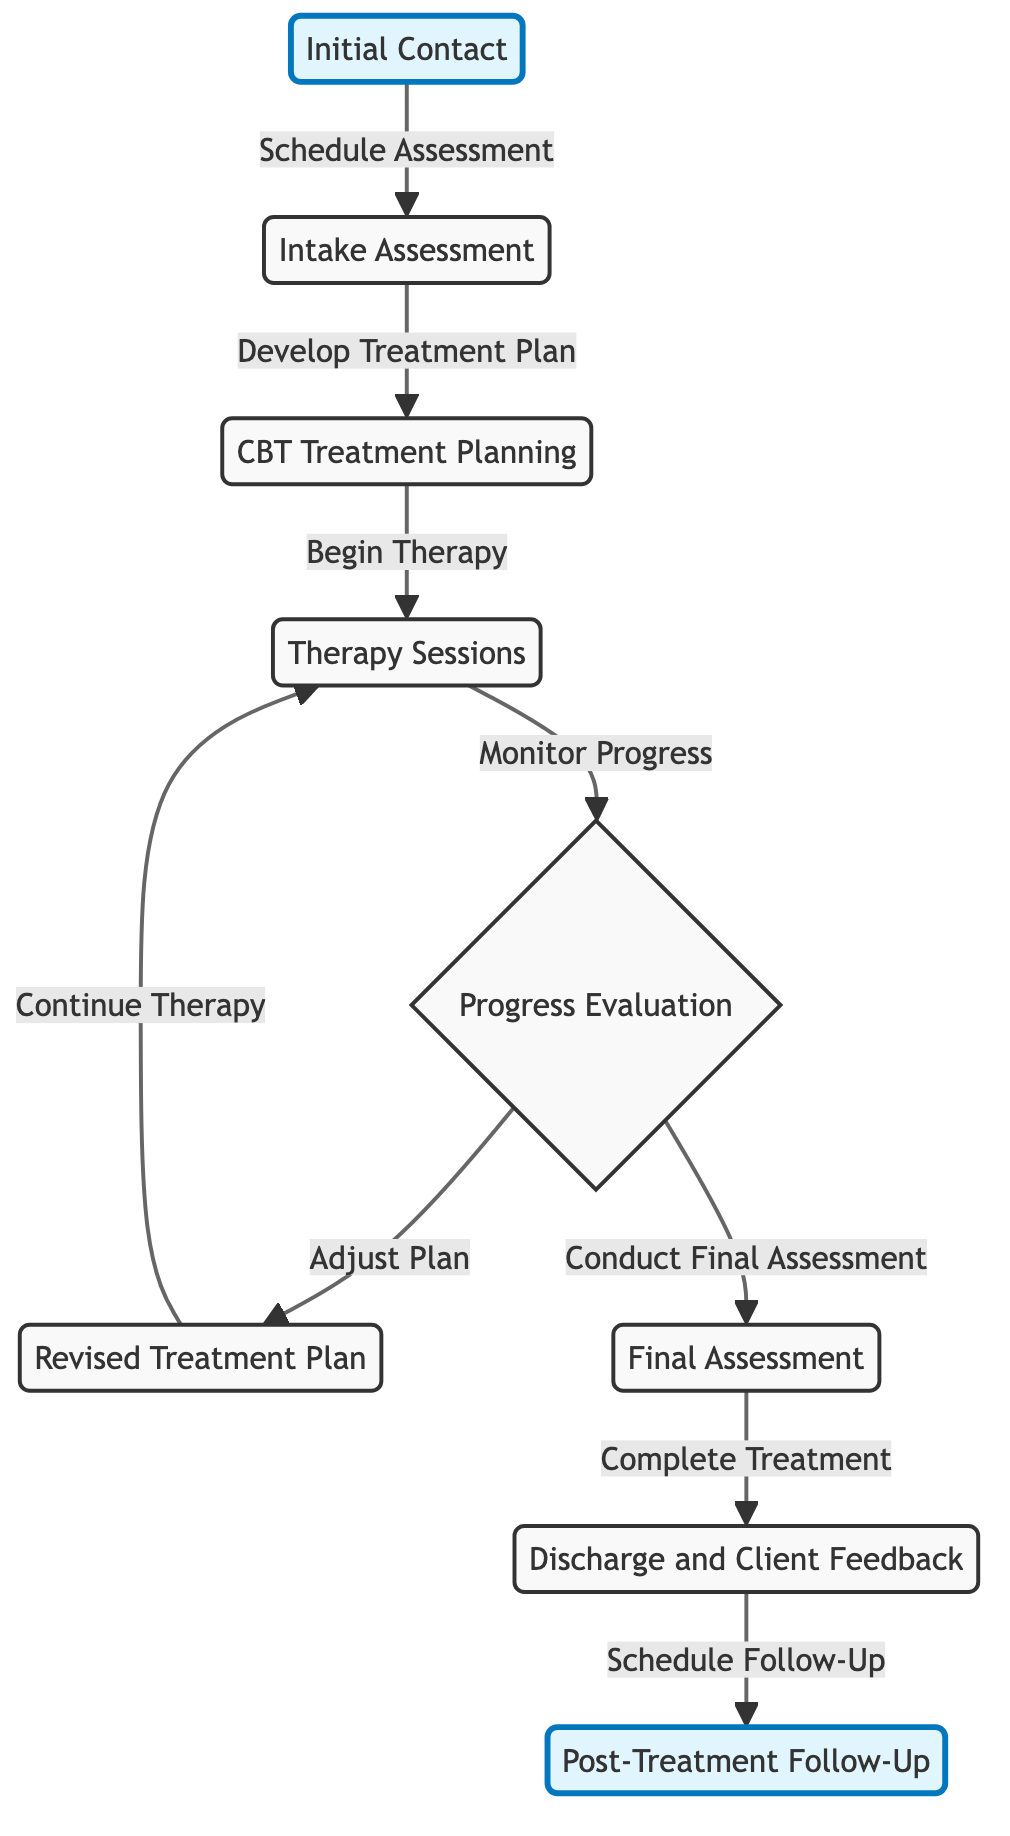What is the first step in the client referral process? The first step in the diagram is the "Initial Contact," which is the starting point of the entire process.
Answer: Initial Contact How many total nodes are represented in the diagram? By counting each unique stage represented in the diagram, we find there are nine nodes in total.
Answer: 9 What is the last step before the Post-Treatment Follow-Up? The last step leading to the "Post-Treatment Follow-Up" is the "Discharge and Client Feedback," which is directly before the follow-up stage.
Answer: Discharge and Client Feedback Which node follows the Progress Evaluation? "Revised Treatment Plan" and "Final Assessment" both follow "Progress Evaluation," as they are two potential outcomes of the evaluation stage.
Answer: Revised Treatment Plan, Final Assessment What label connects the Final Assessment to the Discharge and Client Feedback? The label that connects "Final Assessment" to "Discharge and Client Feedback" is "Complete Treatment," indicating the conclusion of the treatment process.
Answer: Complete Treatment If a client's treatment plan is adjusted, what stage would they return to? If an adjustment is made to a client's treatment plan, they would return to "Therapy Sessions," as indicated by the connection from "Revised Treatment Plan."
Answer: Therapy Sessions What is the relationship between the Intake Assessment and Treatment Planning? The relationship is one of progression; specifically, the "Intake Assessment" leads directly to the next step which is "CBT Treatment Planning" as indicated by the arrow labeled "Develop Treatment Plan."
Answer: Develop Treatment Plan How many edges are there in the diagram? By counting the connections that link the various nodes, there are eight edges present in the diagram.
Answer: 8 What action follows the Therapy Sessions? The action that follows the "Therapy Sessions" is "Progress Evaluation," which assesses how the therapy is progressing.
Answer: Progress Evaluation 